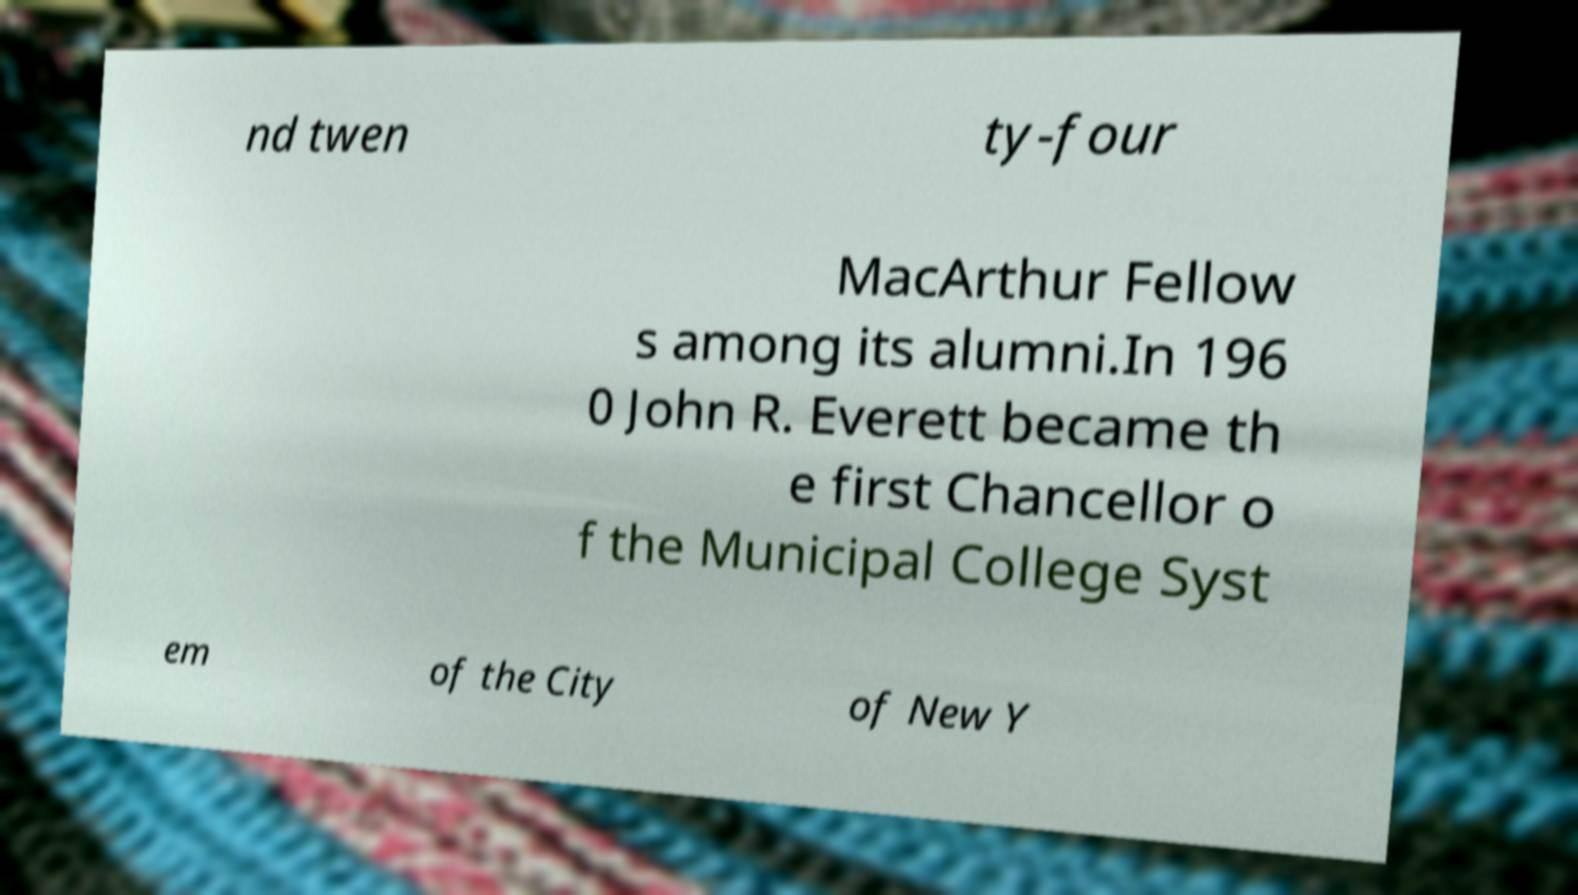I need the written content from this picture converted into text. Can you do that? nd twen ty-four MacArthur Fellow s among its alumni.In 196 0 John R. Everett became th e first Chancellor o f the Municipal College Syst em of the City of New Y 